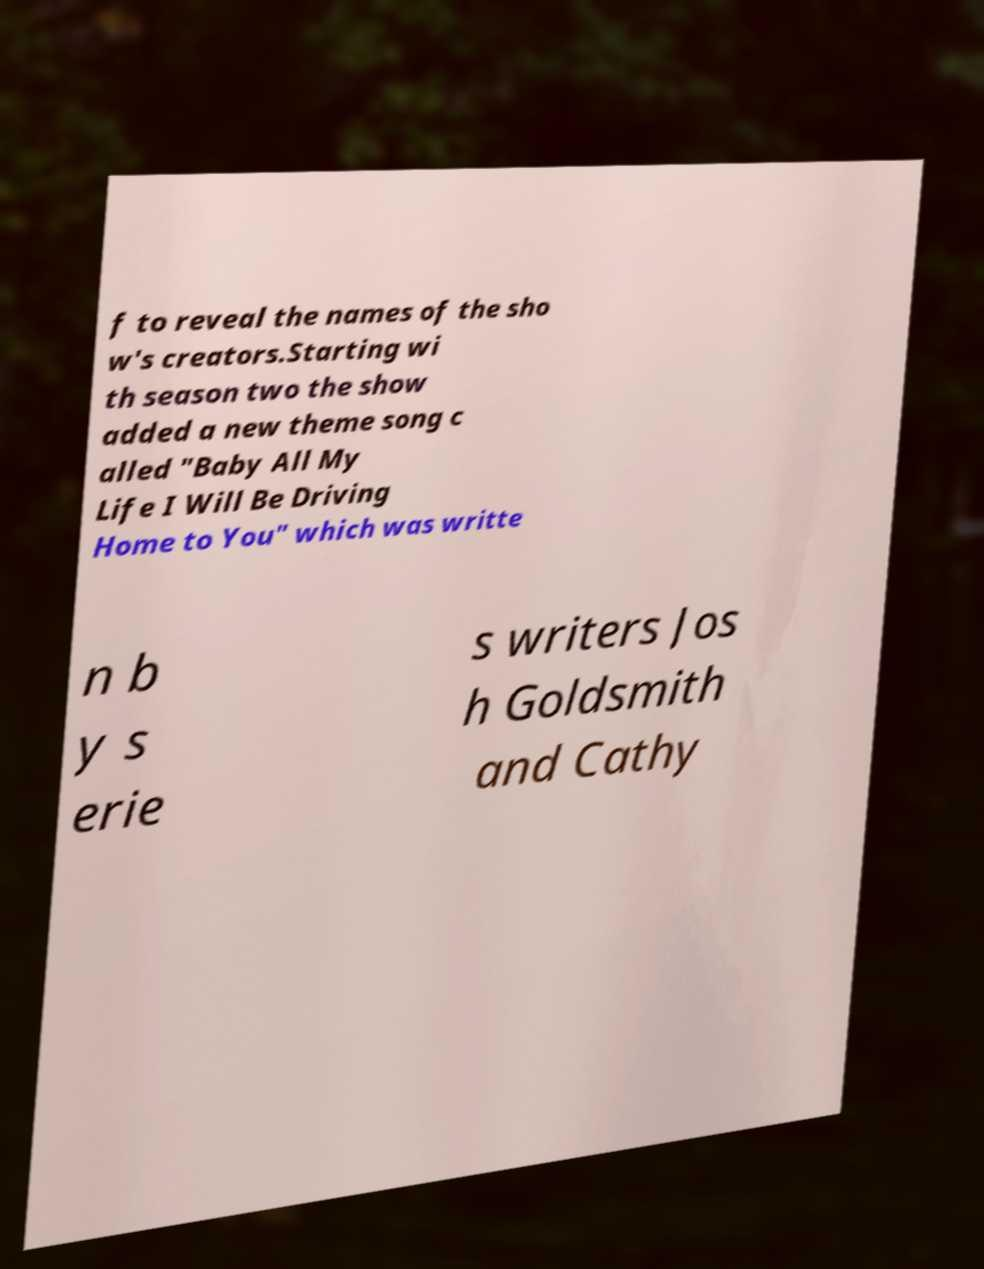Please read and relay the text visible in this image. What does it say? f to reveal the names of the sho w's creators.Starting wi th season two the show added a new theme song c alled "Baby All My Life I Will Be Driving Home to You" which was writte n b y s erie s writers Jos h Goldsmith and Cathy 